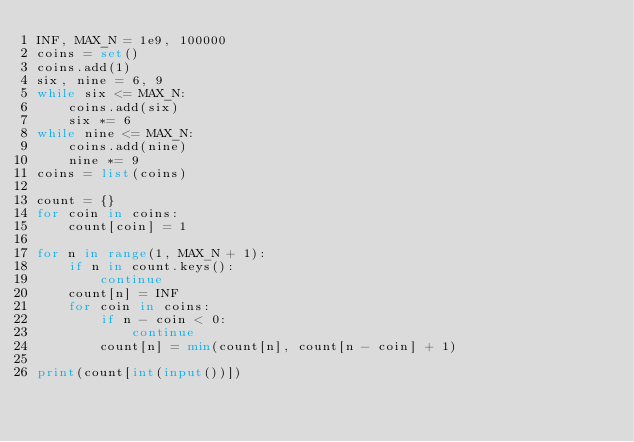<code> <loc_0><loc_0><loc_500><loc_500><_Python_>INF, MAX_N = 1e9, 100000
coins = set()
coins.add(1)
six, nine = 6, 9
while six <= MAX_N:
    coins.add(six)
    six *= 6
while nine <= MAX_N:
    coins.add(nine)
    nine *= 9
coins = list(coins)

count = {}
for coin in coins:
    count[coin] = 1

for n in range(1, MAX_N + 1):
    if n in count.keys():
        continue
    count[n] = INF
    for coin in coins:
        if n - coin < 0:
            continue
        count[n] = min(count[n], count[n - coin] + 1)

print(count[int(input())])</code> 